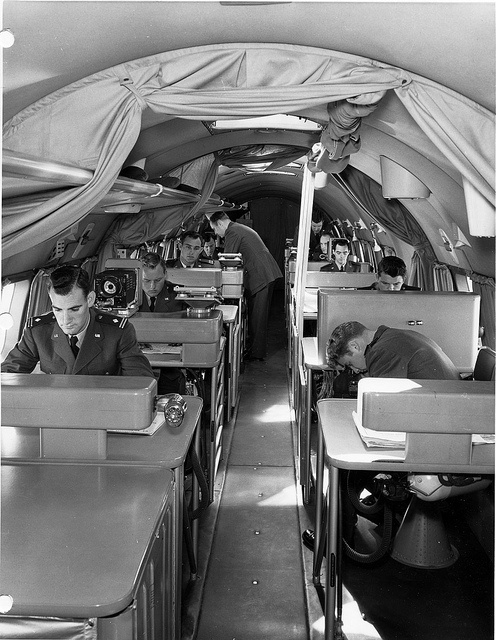Describe the objects in this image and their specific colors. I can see dining table in white, darkgray, gray, lightgray, and black tones, people in white, black, gray, darkgray, and lightgray tones, people in white, gray, black, darkgray, and lightgray tones, people in white, black, gray, darkgray, and lightgray tones, and people in white, black, gray, and lightgray tones in this image. 